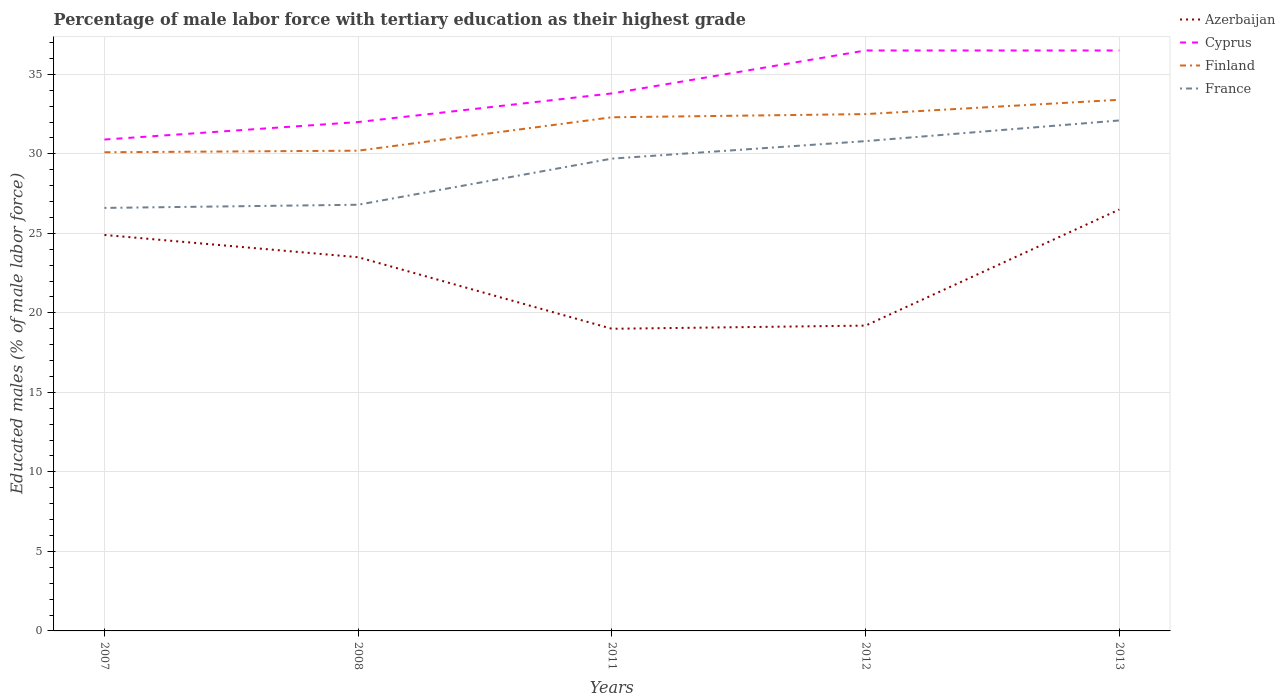Does the line corresponding to Finland intersect with the line corresponding to France?
Ensure brevity in your answer.  No. Is the number of lines equal to the number of legend labels?
Give a very brief answer. Yes. Across all years, what is the maximum percentage of male labor force with tertiary education in Finland?
Give a very brief answer. 30.1. In which year was the percentage of male labor force with tertiary education in France maximum?
Your answer should be compact. 2007. What is the difference between the highest and the second highest percentage of male labor force with tertiary education in Finland?
Provide a succinct answer. 3.3. How many years are there in the graph?
Keep it short and to the point. 5. What is the difference between two consecutive major ticks on the Y-axis?
Provide a succinct answer. 5. Are the values on the major ticks of Y-axis written in scientific E-notation?
Offer a terse response. No. Does the graph contain grids?
Offer a very short reply. Yes. How many legend labels are there?
Make the answer very short. 4. How are the legend labels stacked?
Provide a succinct answer. Vertical. What is the title of the graph?
Offer a very short reply. Percentage of male labor force with tertiary education as their highest grade. Does "Papua New Guinea" appear as one of the legend labels in the graph?
Your answer should be compact. No. What is the label or title of the X-axis?
Give a very brief answer. Years. What is the label or title of the Y-axis?
Provide a short and direct response. Educated males (% of male labor force). What is the Educated males (% of male labor force) in Azerbaijan in 2007?
Keep it short and to the point. 24.9. What is the Educated males (% of male labor force) in Cyprus in 2007?
Offer a terse response. 30.9. What is the Educated males (% of male labor force) of Finland in 2007?
Your answer should be very brief. 30.1. What is the Educated males (% of male labor force) in France in 2007?
Your answer should be very brief. 26.6. What is the Educated males (% of male labor force) of Finland in 2008?
Your answer should be compact. 30.2. What is the Educated males (% of male labor force) of France in 2008?
Your answer should be compact. 26.8. What is the Educated males (% of male labor force) of Azerbaijan in 2011?
Offer a very short reply. 19. What is the Educated males (% of male labor force) of Cyprus in 2011?
Your answer should be compact. 33.8. What is the Educated males (% of male labor force) in Finland in 2011?
Ensure brevity in your answer.  32.3. What is the Educated males (% of male labor force) in France in 2011?
Your answer should be compact. 29.7. What is the Educated males (% of male labor force) in Azerbaijan in 2012?
Your answer should be compact. 19.2. What is the Educated males (% of male labor force) in Cyprus in 2012?
Make the answer very short. 36.5. What is the Educated males (% of male labor force) of Finland in 2012?
Make the answer very short. 32.5. What is the Educated males (% of male labor force) of France in 2012?
Provide a short and direct response. 30.8. What is the Educated males (% of male labor force) in Cyprus in 2013?
Keep it short and to the point. 36.5. What is the Educated males (% of male labor force) of Finland in 2013?
Make the answer very short. 33.4. What is the Educated males (% of male labor force) of France in 2013?
Your answer should be compact. 32.1. Across all years, what is the maximum Educated males (% of male labor force) in Azerbaijan?
Provide a succinct answer. 26.5. Across all years, what is the maximum Educated males (% of male labor force) in Cyprus?
Offer a very short reply. 36.5. Across all years, what is the maximum Educated males (% of male labor force) of Finland?
Offer a very short reply. 33.4. Across all years, what is the maximum Educated males (% of male labor force) in France?
Offer a very short reply. 32.1. Across all years, what is the minimum Educated males (% of male labor force) of Azerbaijan?
Keep it short and to the point. 19. Across all years, what is the minimum Educated males (% of male labor force) in Cyprus?
Offer a terse response. 30.9. Across all years, what is the minimum Educated males (% of male labor force) in Finland?
Give a very brief answer. 30.1. Across all years, what is the minimum Educated males (% of male labor force) of France?
Your response must be concise. 26.6. What is the total Educated males (% of male labor force) in Azerbaijan in the graph?
Your response must be concise. 113.1. What is the total Educated males (% of male labor force) in Cyprus in the graph?
Provide a succinct answer. 169.7. What is the total Educated males (% of male labor force) in Finland in the graph?
Give a very brief answer. 158.5. What is the total Educated males (% of male labor force) of France in the graph?
Your response must be concise. 146. What is the difference between the Educated males (% of male labor force) in Azerbaijan in 2007 and that in 2008?
Your response must be concise. 1.4. What is the difference between the Educated males (% of male labor force) in Azerbaijan in 2007 and that in 2011?
Provide a succinct answer. 5.9. What is the difference between the Educated males (% of male labor force) of Azerbaijan in 2007 and that in 2012?
Your response must be concise. 5.7. What is the difference between the Educated males (% of male labor force) in Cyprus in 2007 and that in 2012?
Give a very brief answer. -5.6. What is the difference between the Educated males (% of male labor force) in France in 2007 and that in 2012?
Keep it short and to the point. -4.2. What is the difference between the Educated males (% of male labor force) of Azerbaijan in 2007 and that in 2013?
Ensure brevity in your answer.  -1.6. What is the difference between the Educated males (% of male labor force) of Finland in 2007 and that in 2013?
Provide a short and direct response. -3.3. What is the difference between the Educated males (% of male labor force) in France in 2007 and that in 2013?
Your response must be concise. -5.5. What is the difference between the Educated males (% of male labor force) of Azerbaijan in 2008 and that in 2011?
Offer a terse response. 4.5. What is the difference between the Educated males (% of male labor force) of Finland in 2008 and that in 2012?
Your response must be concise. -2.3. What is the difference between the Educated males (% of male labor force) of France in 2008 and that in 2012?
Offer a terse response. -4. What is the difference between the Educated males (% of male labor force) of Cyprus in 2008 and that in 2013?
Give a very brief answer. -4.5. What is the difference between the Educated males (% of male labor force) in Finland in 2011 and that in 2012?
Provide a succinct answer. -0.2. What is the difference between the Educated males (% of male labor force) of Azerbaijan in 2011 and that in 2013?
Give a very brief answer. -7.5. What is the difference between the Educated males (% of male labor force) in Cyprus in 2011 and that in 2013?
Provide a succinct answer. -2.7. What is the difference between the Educated males (% of male labor force) in Finland in 2011 and that in 2013?
Your answer should be compact. -1.1. What is the difference between the Educated males (% of male labor force) of Azerbaijan in 2012 and that in 2013?
Offer a terse response. -7.3. What is the difference between the Educated males (% of male labor force) in Cyprus in 2012 and that in 2013?
Offer a very short reply. 0. What is the difference between the Educated males (% of male labor force) of Azerbaijan in 2007 and the Educated males (% of male labor force) of Cyprus in 2008?
Your response must be concise. -7.1. What is the difference between the Educated males (% of male labor force) of Cyprus in 2007 and the Educated males (% of male labor force) of Finland in 2008?
Provide a short and direct response. 0.7. What is the difference between the Educated males (% of male labor force) in Cyprus in 2007 and the Educated males (% of male labor force) in France in 2008?
Your answer should be very brief. 4.1. What is the difference between the Educated males (% of male labor force) in Azerbaijan in 2007 and the Educated males (% of male labor force) in Cyprus in 2011?
Give a very brief answer. -8.9. What is the difference between the Educated males (% of male labor force) of Azerbaijan in 2007 and the Educated males (% of male labor force) of France in 2011?
Offer a terse response. -4.8. What is the difference between the Educated males (% of male labor force) in Cyprus in 2007 and the Educated males (% of male labor force) in Finland in 2011?
Provide a succinct answer. -1.4. What is the difference between the Educated males (% of male labor force) of Cyprus in 2007 and the Educated males (% of male labor force) of France in 2011?
Provide a succinct answer. 1.2. What is the difference between the Educated males (% of male labor force) of Finland in 2007 and the Educated males (% of male labor force) of France in 2011?
Your answer should be compact. 0.4. What is the difference between the Educated males (% of male labor force) in Azerbaijan in 2007 and the Educated males (% of male labor force) in Finland in 2012?
Offer a very short reply. -7.6. What is the difference between the Educated males (% of male labor force) in Azerbaijan in 2007 and the Educated males (% of male labor force) in France in 2012?
Your response must be concise. -5.9. What is the difference between the Educated males (% of male labor force) in Cyprus in 2007 and the Educated males (% of male labor force) in France in 2012?
Provide a succinct answer. 0.1. What is the difference between the Educated males (% of male labor force) in Azerbaijan in 2007 and the Educated males (% of male labor force) in Cyprus in 2013?
Provide a succinct answer. -11.6. What is the difference between the Educated males (% of male labor force) of Azerbaijan in 2007 and the Educated males (% of male labor force) of Finland in 2013?
Provide a succinct answer. -8.5. What is the difference between the Educated males (% of male labor force) in Azerbaijan in 2007 and the Educated males (% of male labor force) in France in 2013?
Make the answer very short. -7.2. What is the difference between the Educated males (% of male labor force) of Cyprus in 2007 and the Educated males (% of male labor force) of France in 2013?
Keep it short and to the point. -1.2. What is the difference between the Educated males (% of male labor force) in Azerbaijan in 2008 and the Educated males (% of male labor force) in Finland in 2011?
Ensure brevity in your answer.  -8.8. What is the difference between the Educated males (% of male labor force) in Cyprus in 2008 and the Educated males (% of male labor force) in France in 2011?
Make the answer very short. 2.3. What is the difference between the Educated males (% of male labor force) in Finland in 2008 and the Educated males (% of male labor force) in France in 2011?
Your answer should be very brief. 0.5. What is the difference between the Educated males (% of male labor force) in Azerbaijan in 2008 and the Educated males (% of male labor force) in Finland in 2012?
Keep it short and to the point. -9. What is the difference between the Educated males (% of male labor force) of Cyprus in 2008 and the Educated males (% of male labor force) of France in 2012?
Your answer should be compact. 1.2. What is the difference between the Educated males (% of male labor force) in Azerbaijan in 2008 and the Educated males (% of male labor force) in Cyprus in 2013?
Provide a short and direct response. -13. What is the difference between the Educated males (% of male labor force) in Azerbaijan in 2011 and the Educated males (% of male labor force) in Cyprus in 2012?
Your answer should be compact. -17.5. What is the difference between the Educated males (% of male labor force) of Azerbaijan in 2011 and the Educated males (% of male labor force) of Finland in 2012?
Your answer should be very brief. -13.5. What is the difference between the Educated males (% of male labor force) of Finland in 2011 and the Educated males (% of male labor force) of France in 2012?
Provide a short and direct response. 1.5. What is the difference between the Educated males (% of male labor force) in Azerbaijan in 2011 and the Educated males (% of male labor force) in Cyprus in 2013?
Your response must be concise. -17.5. What is the difference between the Educated males (% of male labor force) in Azerbaijan in 2011 and the Educated males (% of male labor force) in Finland in 2013?
Make the answer very short. -14.4. What is the difference between the Educated males (% of male labor force) of Azerbaijan in 2011 and the Educated males (% of male labor force) of France in 2013?
Keep it short and to the point. -13.1. What is the difference between the Educated males (% of male labor force) in Cyprus in 2011 and the Educated males (% of male labor force) in France in 2013?
Provide a short and direct response. 1.7. What is the difference between the Educated males (% of male labor force) in Azerbaijan in 2012 and the Educated males (% of male labor force) in Cyprus in 2013?
Offer a very short reply. -17.3. What is the difference between the Educated males (% of male labor force) of Azerbaijan in 2012 and the Educated males (% of male labor force) of France in 2013?
Ensure brevity in your answer.  -12.9. What is the difference between the Educated males (% of male labor force) of Cyprus in 2012 and the Educated males (% of male labor force) of Finland in 2013?
Your answer should be very brief. 3.1. What is the average Educated males (% of male labor force) in Azerbaijan per year?
Offer a terse response. 22.62. What is the average Educated males (% of male labor force) of Cyprus per year?
Offer a very short reply. 33.94. What is the average Educated males (% of male labor force) in Finland per year?
Ensure brevity in your answer.  31.7. What is the average Educated males (% of male labor force) of France per year?
Ensure brevity in your answer.  29.2. In the year 2007, what is the difference between the Educated males (% of male labor force) in Cyprus and Educated males (% of male labor force) in France?
Give a very brief answer. 4.3. In the year 2008, what is the difference between the Educated males (% of male labor force) of Azerbaijan and Educated males (% of male labor force) of Finland?
Give a very brief answer. -6.7. In the year 2008, what is the difference between the Educated males (% of male labor force) of Azerbaijan and Educated males (% of male labor force) of France?
Give a very brief answer. -3.3. In the year 2008, what is the difference between the Educated males (% of male labor force) in Cyprus and Educated males (% of male labor force) in Finland?
Ensure brevity in your answer.  1.8. In the year 2008, what is the difference between the Educated males (% of male labor force) of Cyprus and Educated males (% of male labor force) of France?
Make the answer very short. 5.2. In the year 2011, what is the difference between the Educated males (% of male labor force) in Azerbaijan and Educated males (% of male labor force) in Cyprus?
Offer a very short reply. -14.8. In the year 2011, what is the difference between the Educated males (% of male labor force) in Azerbaijan and Educated males (% of male labor force) in Finland?
Give a very brief answer. -13.3. In the year 2011, what is the difference between the Educated males (% of male labor force) in Azerbaijan and Educated males (% of male labor force) in France?
Your answer should be very brief. -10.7. In the year 2011, what is the difference between the Educated males (% of male labor force) in Cyprus and Educated males (% of male labor force) in Finland?
Offer a terse response. 1.5. In the year 2011, what is the difference between the Educated males (% of male labor force) of Cyprus and Educated males (% of male labor force) of France?
Provide a succinct answer. 4.1. In the year 2011, what is the difference between the Educated males (% of male labor force) in Finland and Educated males (% of male labor force) in France?
Ensure brevity in your answer.  2.6. In the year 2012, what is the difference between the Educated males (% of male labor force) of Azerbaijan and Educated males (% of male labor force) of Cyprus?
Your answer should be compact. -17.3. In the year 2012, what is the difference between the Educated males (% of male labor force) in Azerbaijan and Educated males (% of male labor force) in France?
Provide a short and direct response. -11.6. In the year 2012, what is the difference between the Educated males (% of male labor force) in Cyprus and Educated males (% of male labor force) in France?
Provide a succinct answer. 5.7. In the year 2013, what is the difference between the Educated males (% of male labor force) of Azerbaijan and Educated males (% of male labor force) of Cyprus?
Your answer should be compact. -10. In the year 2013, what is the difference between the Educated males (% of male labor force) of Azerbaijan and Educated males (% of male labor force) of France?
Your answer should be compact. -5.6. In the year 2013, what is the difference between the Educated males (% of male labor force) of Cyprus and Educated males (% of male labor force) of Finland?
Make the answer very short. 3.1. In the year 2013, what is the difference between the Educated males (% of male labor force) of Cyprus and Educated males (% of male labor force) of France?
Offer a terse response. 4.4. What is the ratio of the Educated males (% of male labor force) of Azerbaijan in 2007 to that in 2008?
Offer a very short reply. 1.06. What is the ratio of the Educated males (% of male labor force) of Cyprus in 2007 to that in 2008?
Provide a short and direct response. 0.97. What is the ratio of the Educated males (% of male labor force) of Finland in 2007 to that in 2008?
Ensure brevity in your answer.  1. What is the ratio of the Educated males (% of male labor force) of Azerbaijan in 2007 to that in 2011?
Your answer should be compact. 1.31. What is the ratio of the Educated males (% of male labor force) in Cyprus in 2007 to that in 2011?
Your response must be concise. 0.91. What is the ratio of the Educated males (% of male labor force) of Finland in 2007 to that in 2011?
Your response must be concise. 0.93. What is the ratio of the Educated males (% of male labor force) of France in 2007 to that in 2011?
Offer a terse response. 0.9. What is the ratio of the Educated males (% of male labor force) of Azerbaijan in 2007 to that in 2012?
Your answer should be compact. 1.3. What is the ratio of the Educated males (% of male labor force) in Cyprus in 2007 to that in 2012?
Provide a succinct answer. 0.85. What is the ratio of the Educated males (% of male labor force) of Finland in 2007 to that in 2012?
Provide a short and direct response. 0.93. What is the ratio of the Educated males (% of male labor force) in France in 2007 to that in 2012?
Your answer should be compact. 0.86. What is the ratio of the Educated males (% of male labor force) of Azerbaijan in 2007 to that in 2013?
Your answer should be compact. 0.94. What is the ratio of the Educated males (% of male labor force) in Cyprus in 2007 to that in 2013?
Keep it short and to the point. 0.85. What is the ratio of the Educated males (% of male labor force) of Finland in 2007 to that in 2013?
Your answer should be compact. 0.9. What is the ratio of the Educated males (% of male labor force) in France in 2007 to that in 2013?
Provide a short and direct response. 0.83. What is the ratio of the Educated males (% of male labor force) of Azerbaijan in 2008 to that in 2011?
Your answer should be very brief. 1.24. What is the ratio of the Educated males (% of male labor force) of Cyprus in 2008 to that in 2011?
Provide a succinct answer. 0.95. What is the ratio of the Educated males (% of male labor force) of Finland in 2008 to that in 2011?
Ensure brevity in your answer.  0.94. What is the ratio of the Educated males (% of male labor force) of France in 2008 to that in 2011?
Provide a short and direct response. 0.9. What is the ratio of the Educated males (% of male labor force) of Azerbaijan in 2008 to that in 2012?
Your response must be concise. 1.22. What is the ratio of the Educated males (% of male labor force) of Cyprus in 2008 to that in 2012?
Offer a terse response. 0.88. What is the ratio of the Educated males (% of male labor force) in Finland in 2008 to that in 2012?
Your answer should be very brief. 0.93. What is the ratio of the Educated males (% of male labor force) of France in 2008 to that in 2012?
Your answer should be compact. 0.87. What is the ratio of the Educated males (% of male labor force) in Azerbaijan in 2008 to that in 2013?
Your response must be concise. 0.89. What is the ratio of the Educated males (% of male labor force) of Cyprus in 2008 to that in 2013?
Give a very brief answer. 0.88. What is the ratio of the Educated males (% of male labor force) of Finland in 2008 to that in 2013?
Provide a succinct answer. 0.9. What is the ratio of the Educated males (% of male labor force) of France in 2008 to that in 2013?
Keep it short and to the point. 0.83. What is the ratio of the Educated males (% of male labor force) of Azerbaijan in 2011 to that in 2012?
Your response must be concise. 0.99. What is the ratio of the Educated males (% of male labor force) in Cyprus in 2011 to that in 2012?
Your answer should be very brief. 0.93. What is the ratio of the Educated males (% of male labor force) of France in 2011 to that in 2012?
Give a very brief answer. 0.96. What is the ratio of the Educated males (% of male labor force) in Azerbaijan in 2011 to that in 2013?
Make the answer very short. 0.72. What is the ratio of the Educated males (% of male labor force) in Cyprus in 2011 to that in 2013?
Your answer should be compact. 0.93. What is the ratio of the Educated males (% of male labor force) of Finland in 2011 to that in 2013?
Your response must be concise. 0.97. What is the ratio of the Educated males (% of male labor force) of France in 2011 to that in 2013?
Your response must be concise. 0.93. What is the ratio of the Educated males (% of male labor force) of Azerbaijan in 2012 to that in 2013?
Provide a short and direct response. 0.72. What is the ratio of the Educated males (% of male labor force) of Cyprus in 2012 to that in 2013?
Offer a terse response. 1. What is the ratio of the Educated males (% of male labor force) of Finland in 2012 to that in 2013?
Provide a short and direct response. 0.97. What is the ratio of the Educated males (% of male labor force) of France in 2012 to that in 2013?
Keep it short and to the point. 0.96. What is the difference between the highest and the second highest Educated males (% of male labor force) of France?
Make the answer very short. 1.3. What is the difference between the highest and the lowest Educated males (% of male labor force) in Cyprus?
Provide a short and direct response. 5.6. What is the difference between the highest and the lowest Educated males (% of male labor force) of Finland?
Provide a succinct answer. 3.3. What is the difference between the highest and the lowest Educated males (% of male labor force) of France?
Your answer should be very brief. 5.5. 